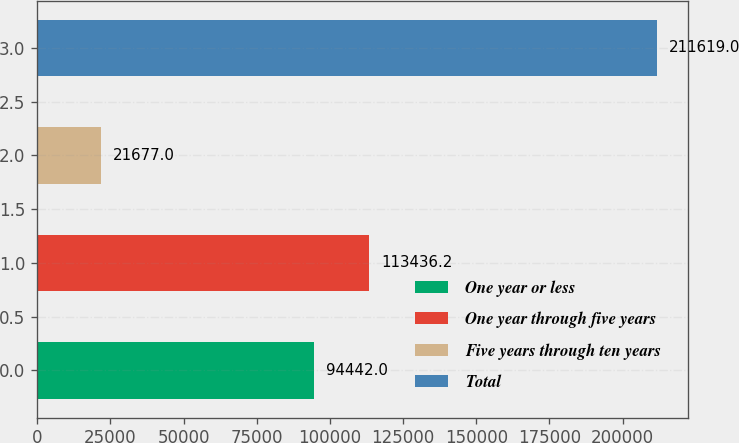Convert chart to OTSL. <chart><loc_0><loc_0><loc_500><loc_500><bar_chart><fcel>One year or less<fcel>One year through five years<fcel>Five years through ten years<fcel>Total<nl><fcel>94442<fcel>113436<fcel>21677<fcel>211619<nl></chart> 